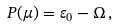Convert formula to latex. <formula><loc_0><loc_0><loc_500><loc_500>P ( \mu ) = \varepsilon _ { 0 } - \Omega \, ,</formula> 